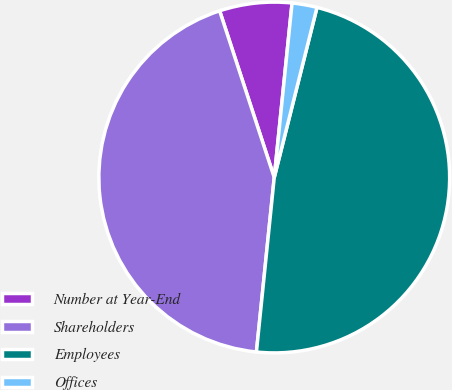Convert chart. <chart><loc_0><loc_0><loc_500><loc_500><pie_chart><fcel>Number at Year-End<fcel>Shareholders<fcel>Employees<fcel>Offices<nl><fcel>6.66%<fcel>43.34%<fcel>47.7%<fcel>2.3%<nl></chart> 